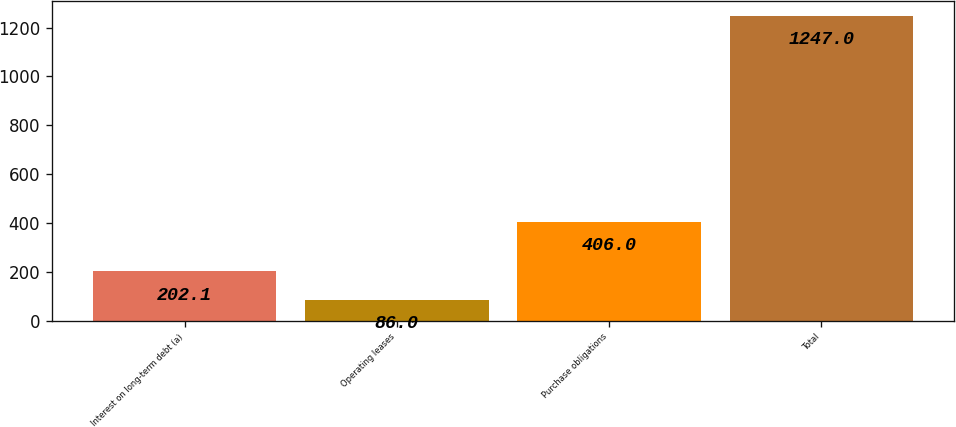Convert chart to OTSL. <chart><loc_0><loc_0><loc_500><loc_500><bar_chart><fcel>Interest on long-term debt (a)<fcel>Operating leases<fcel>Purchase obligations<fcel>Total<nl><fcel>202.1<fcel>86<fcel>406<fcel>1247<nl></chart> 